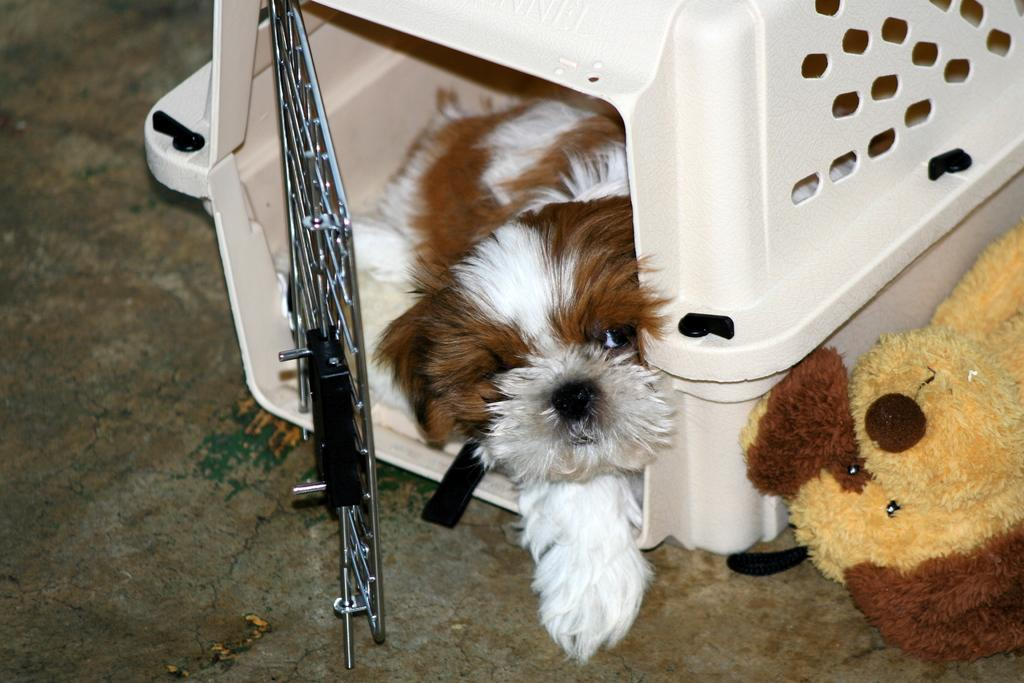What type of animal is in the image? There is a dog in the image. Can you describe the dog's coloring? The dog has white and brown coloring. Where is the dog located in the image? The dog is in a white color cage. What other dog-related item is in the image? There is a toy dog in the image. How is the toy dog different from the real dog in terms of coloring? The toy dog has brown and cream coloring. What type of vase is being smashed by the dog in the image? There is no vase present in the image, and the dog is not smashing anything. 